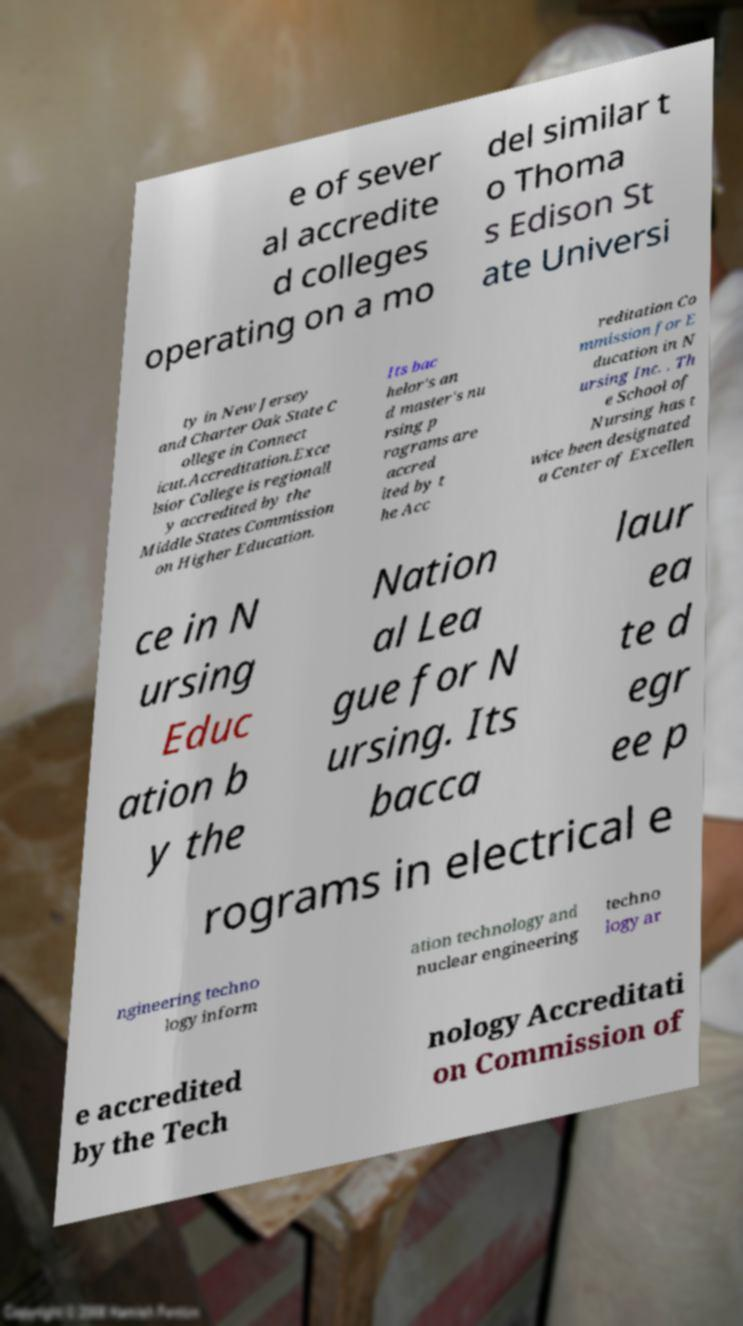What messages or text are displayed in this image? I need them in a readable, typed format. e of sever al accredite d colleges operating on a mo del similar t o Thoma s Edison St ate Universi ty in New Jersey and Charter Oak State C ollege in Connect icut.Accreditation.Exce lsior College is regionall y accredited by the Middle States Commission on Higher Education. Its bac helor's an d master's nu rsing p rograms are accred ited by t he Acc reditation Co mmission for E ducation in N ursing Inc. . Th e School of Nursing has t wice been designated a Center of Excellen ce in N ursing Educ ation b y the Nation al Lea gue for N ursing. Its bacca laur ea te d egr ee p rograms in electrical e ngineering techno logy inform ation technology and nuclear engineering techno logy ar e accredited by the Tech nology Accreditati on Commission of 